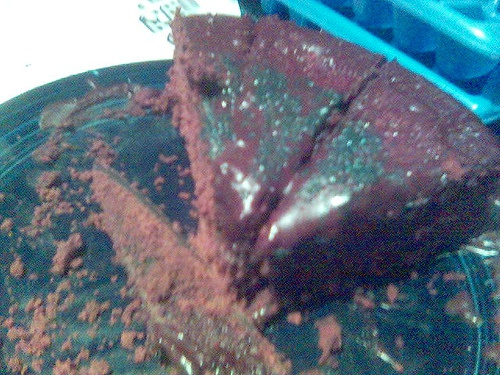Describe the objects in this image and their specific colors. I can see cake in white, gray, black, and navy tones and knife in white and gray tones in this image. 